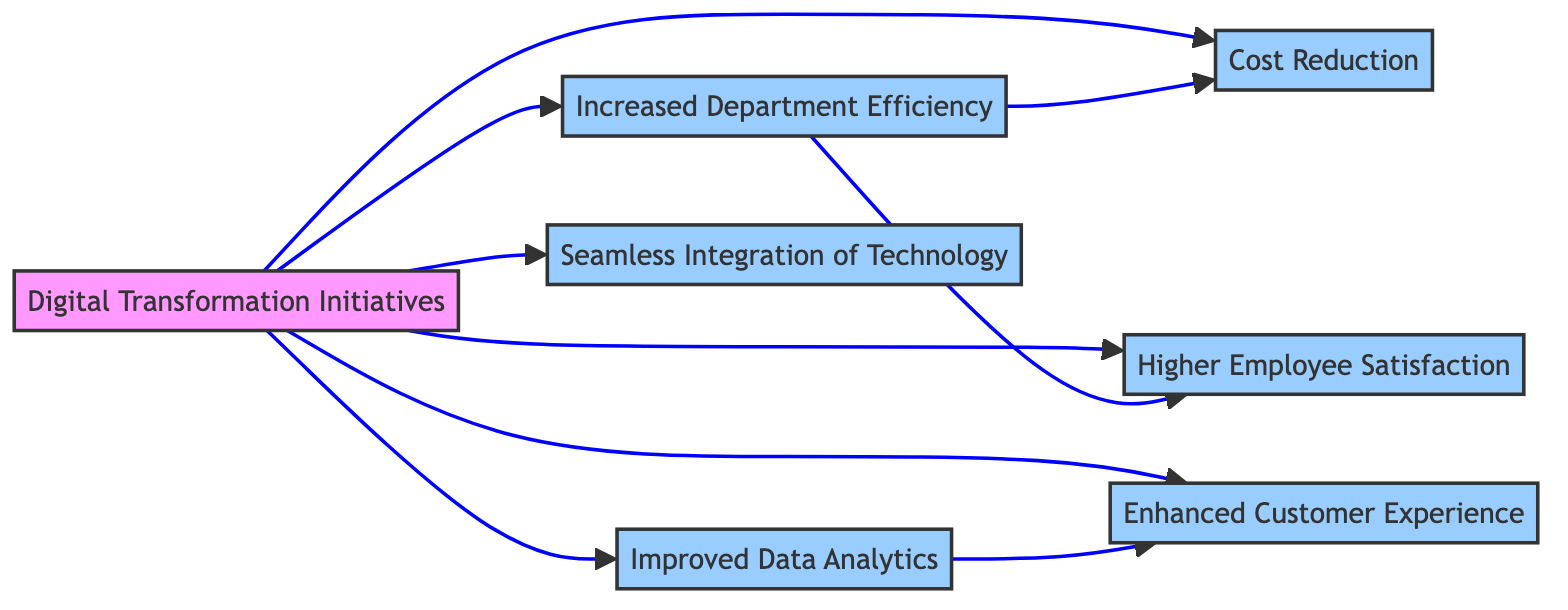What is the main focus of the diagram? The diagram focuses on the impact of Digital Transformation Initiatives on various aspects of department efficiency and effectiveness.
Answer: Digital Transformation Initiatives How many nodes are there in the diagram? There are a total of 7 nodes, which represent different elements related to digital transformation and its impacts.
Answer: 7 Which node is directly affected by Digital Transformation Initiatives? Digital Transformation Initiatives directly affects Increased Department Efficiency, Cost Reduction, Higher Employee Satisfaction, Enhanced Customer Experience, Improved Data Analytics, and Seamless Integration of Technology.
Answer: Increased Department Efficiency, Cost Reduction, Higher Employee Satisfaction, Enhanced Customer Experience, Improved Data Analytics, Seamless Integration of Technology What is the relationship between Increased Department Efficiency and Cost Reduction? Increased Department Efficiency leads to Cost Reduction, suggesting that as departments become more efficient, they also reduce costs.
Answer: Increased Department Efficiency leads to Cost Reduction Which node enhances Customer Experience according to the diagram? Enhanced Customer Experience is the result of Improved Data Analytics, demonstrating that better data handling can lead to a better experience for customers.
Answer: Improved Data Analytics How many edges are outgoing from the Digital Transformation Initiatives node? There are 6 outgoing edges from the Digital Transformation Initiatives node, connecting it to various effect nodes.
Answer: 6 Which node serves as a prerequisite for Enhanced Customer Experience? Improved Data Analytics serves as a prerequisite for Enhanced Customer Experience, indicating that better data analysis is necessary before customer experience can be enhanced.
Answer: Improved Data Analytics What is the effect of Improved Data Analytics on other nodes? Improved Data Analytics has a direct effect on Enhanced Customer Experience as indicated by the directed edge from Improved Data Analytics to Enhanced Customer Experience.
Answer: Enhanced Customer Experience What impacts does Increased Department Efficiency have? Increased Department Efficiency impacts both Cost Reduction and Higher Employee Satisfaction, indicating benefits in both financial and employee morale aspects.
Answer: Cost Reduction, Higher Employee Satisfaction 